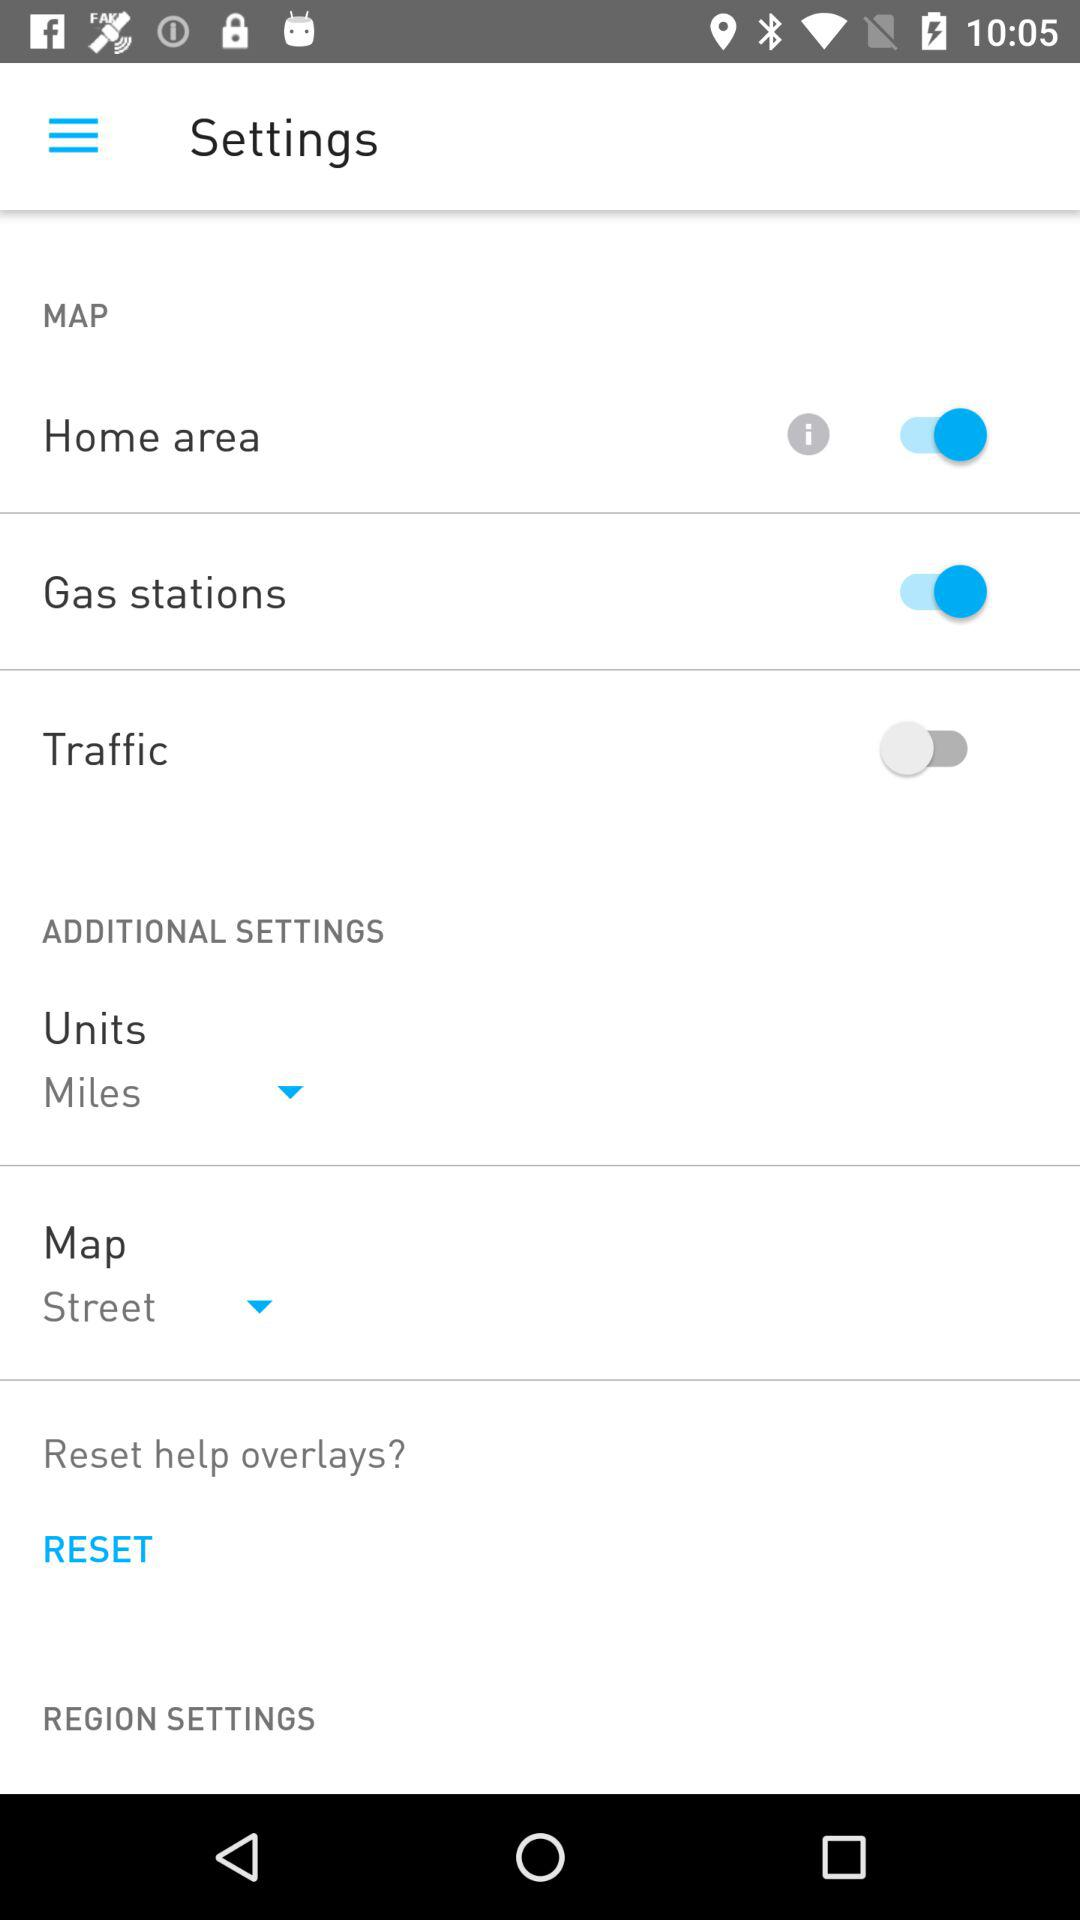What is the status of "Traffic"? The status of "Traffic" is "off". 